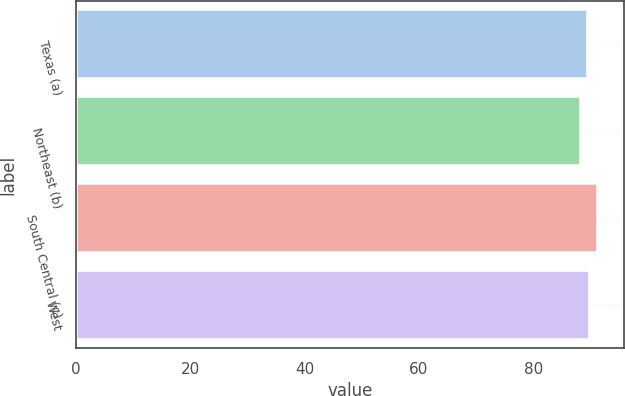Convert chart. <chart><loc_0><loc_0><loc_500><loc_500><bar_chart><fcel>Texas (a)<fcel>Northeast (b)<fcel>South Central (c)<fcel>West<nl><fcel>89.6<fcel>88.3<fcel>91.3<fcel>89.9<nl></chart> 